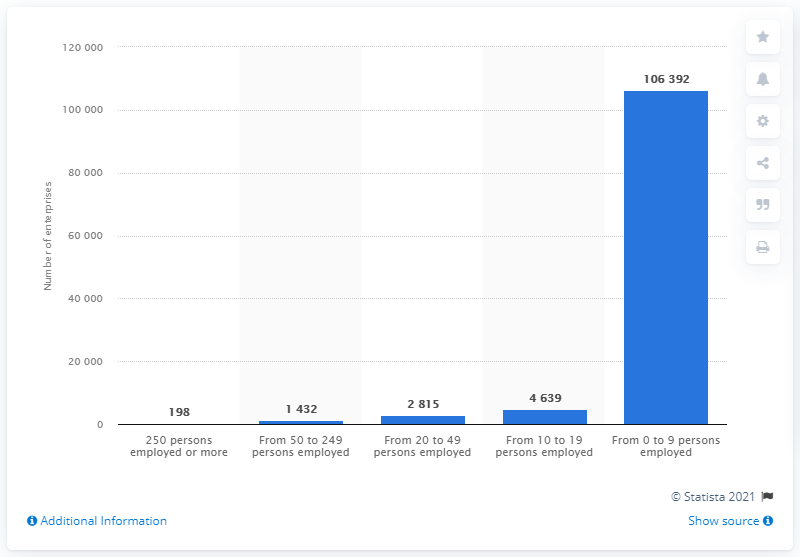Specify some key components in this picture. In 2016, there were 198 enterprises in Latvia with 250 or more employees. 